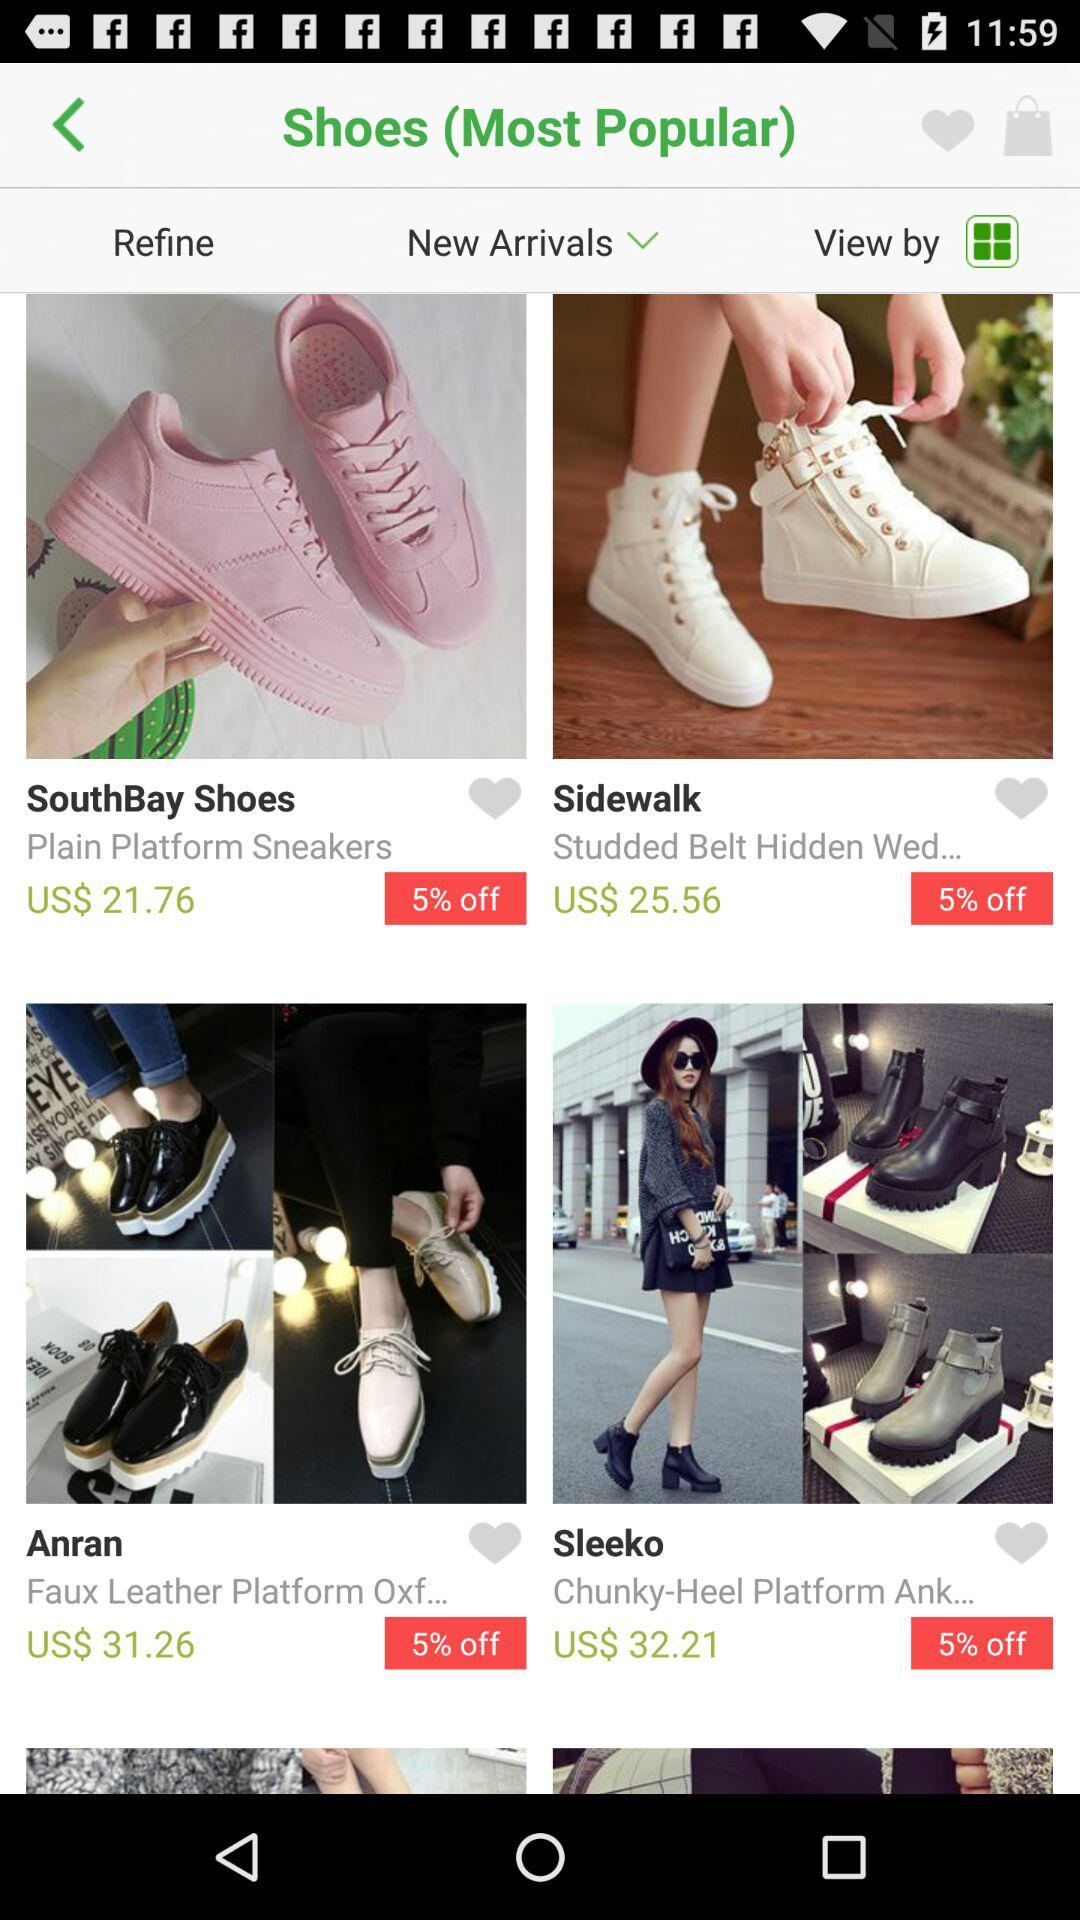Which shoe is more expensive, the Sleeko or the Sidewalk?
Answer the question using a single word or phrase. Sleeko 